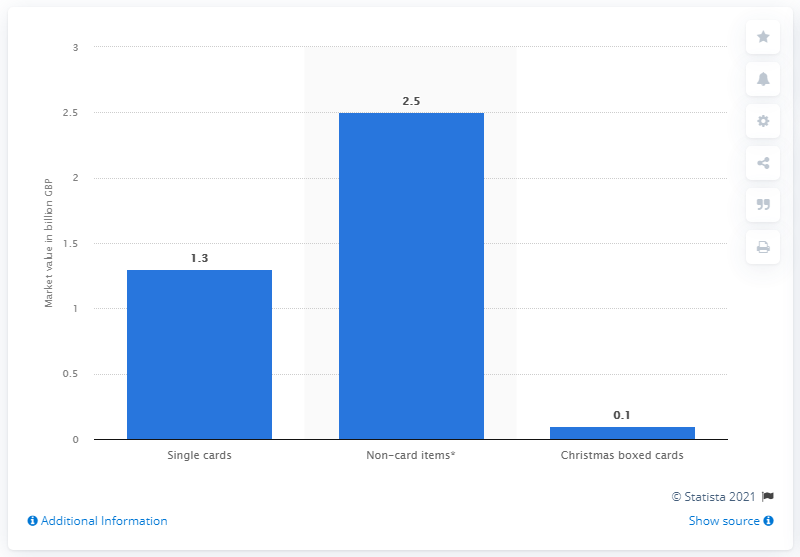Give some essential details in this illustration. In 2017, the retail market for single greeting cards in the UK was valued at approximately 1.3... 